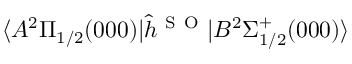<formula> <loc_0><loc_0><loc_500><loc_500>\langle A ^ { 2 } \Pi _ { 1 / 2 } ( 0 0 0 ) | \hat { h } ^ { S O } | B ^ { 2 } \Sigma _ { 1 / 2 } ^ { + } ( 0 0 0 ) \rangle</formula> 